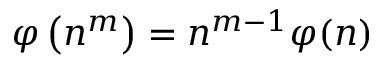Convert formula to latex. <formula><loc_0><loc_0><loc_500><loc_500>\varphi \left ( n ^ { m } \right ) = n ^ { m - 1 } \varphi ( n )</formula> 